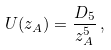Convert formula to latex. <formula><loc_0><loc_0><loc_500><loc_500>U ( z _ { A } ) = \frac { D _ { 5 } } { z _ { A } ^ { 5 } } \, ,</formula> 